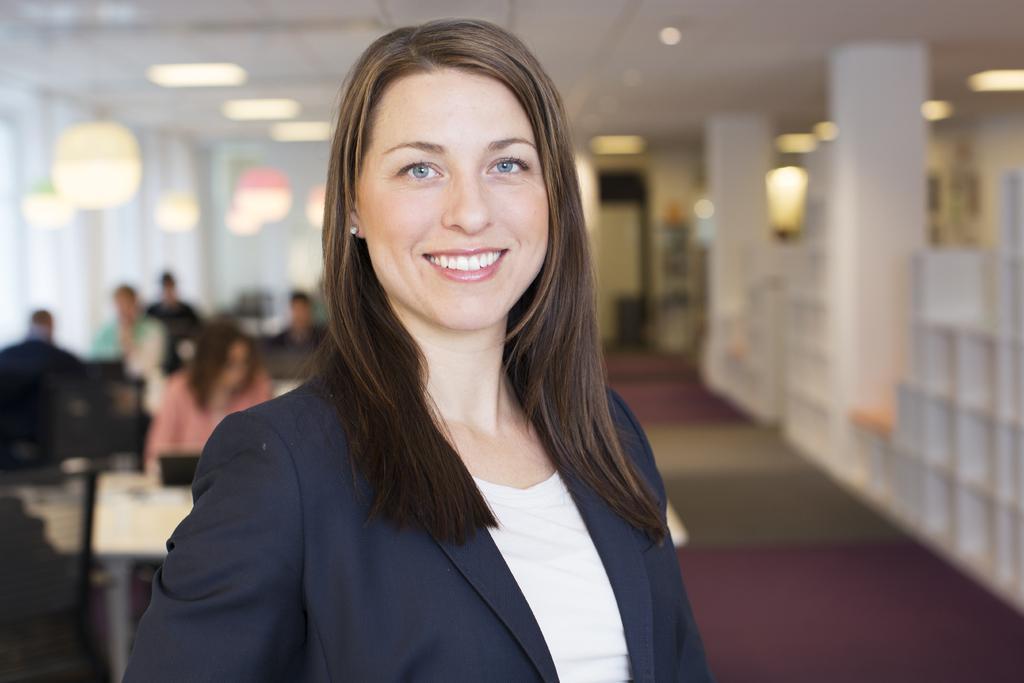Please provide a concise description of this image. In this image we can see a woman is standing, she is smiling, at the back there are group of persons sitting, there are lights, there it is blurry. 